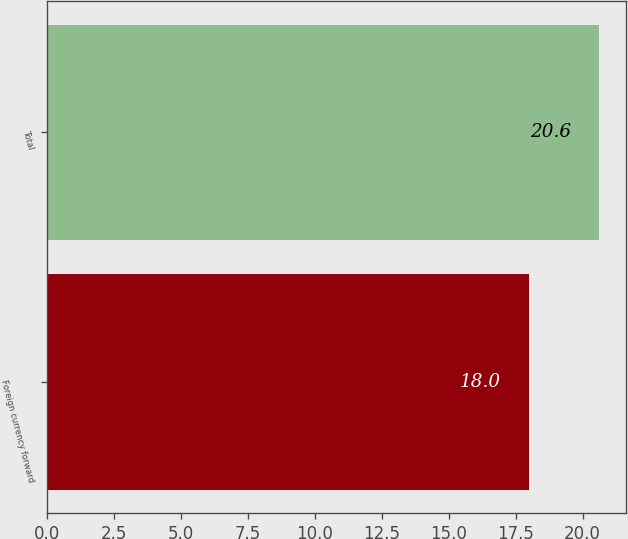Convert chart to OTSL. <chart><loc_0><loc_0><loc_500><loc_500><bar_chart><fcel>Foreign currency forward<fcel>Total<nl><fcel>18<fcel>20.6<nl></chart> 